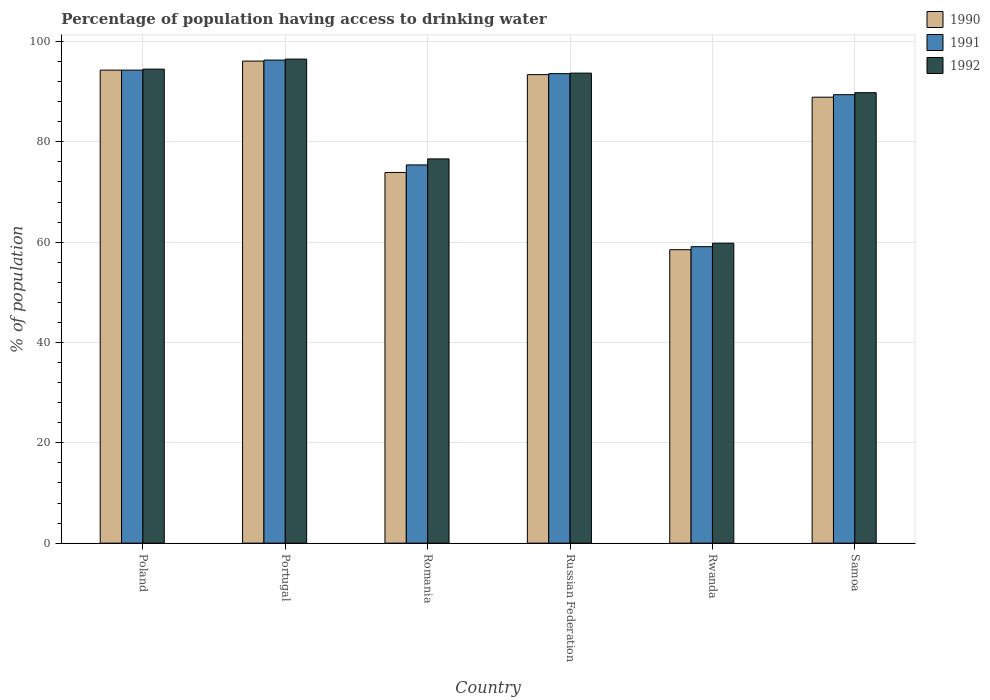How many different coloured bars are there?
Give a very brief answer. 3. How many groups of bars are there?
Your response must be concise. 6. Are the number of bars per tick equal to the number of legend labels?
Keep it short and to the point. Yes. How many bars are there on the 2nd tick from the left?
Your response must be concise. 3. How many bars are there on the 6th tick from the right?
Provide a succinct answer. 3. What is the label of the 6th group of bars from the left?
Offer a very short reply. Samoa. In how many cases, is the number of bars for a given country not equal to the number of legend labels?
Give a very brief answer. 0. What is the percentage of population having access to drinking water in 1992 in Poland?
Offer a terse response. 94.5. Across all countries, what is the maximum percentage of population having access to drinking water in 1990?
Your answer should be compact. 96.1. Across all countries, what is the minimum percentage of population having access to drinking water in 1992?
Your answer should be compact. 59.8. In which country was the percentage of population having access to drinking water in 1991 minimum?
Provide a short and direct response. Rwanda. What is the total percentage of population having access to drinking water in 1992 in the graph?
Provide a succinct answer. 510.9. What is the difference between the percentage of population having access to drinking water in 1991 in Russian Federation and that in Samoa?
Your response must be concise. 4.2. What is the difference between the percentage of population having access to drinking water in 1990 in Samoa and the percentage of population having access to drinking water in 1992 in Russian Federation?
Ensure brevity in your answer.  -4.8. What is the average percentage of population having access to drinking water in 1992 per country?
Your response must be concise. 85.15. What is the difference between the percentage of population having access to drinking water of/in 1990 and percentage of population having access to drinking water of/in 1991 in Portugal?
Make the answer very short. -0.2. What is the ratio of the percentage of population having access to drinking water in 1991 in Russian Federation to that in Rwanda?
Offer a very short reply. 1.58. Is the percentage of population having access to drinking water in 1992 in Romania less than that in Russian Federation?
Provide a succinct answer. Yes. Is the difference between the percentage of population having access to drinking water in 1990 in Russian Federation and Rwanda greater than the difference between the percentage of population having access to drinking water in 1991 in Russian Federation and Rwanda?
Make the answer very short. Yes. What is the difference between the highest and the second highest percentage of population having access to drinking water in 1990?
Give a very brief answer. 2.7. What is the difference between the highest and the lowest percentage of population having access to drinking water in 1992?
Ensure brevity in your answer.  36.7. How many bars are there?
Your response must be concise. 18. What is the difference between two consecutive major ticks on the Y-axis?
Make the answer very short. 20. Are the values on the major ticks of Y-axis written in scientific E-notation?
Your response must be concise. No. Does the graph contain any zero values?
Offer a terse response. No. Does the graph contain grids?
Provide a succinct answer. Yes. What is the title of the graph?
Keep it short and to the point. Percentage of population having access to drinking water. What is the label or title of the Y-axis?
Give a very brief answer. % of population. What is the % of population of 1990 in Poland?
Make the answer very short. 94.3. What is the % of population in 1991 in Poland?
Your response must be concise. 94.3. What is the % of population in 1992 in Poland?
Provide a succinct answer. 94.5. What is the % of population in 1990 in Portugal?
Ensure brevity in your answer.  96.1. What is the % of population of 1991 in Portugal?
Keep it short and to the point. 96.3. What is the % of population of 1992 in Portugal?
Your answer should be very brief. 96.5. What is the % of population in 1990 in Romania?
Your answer should be compact. 73.9. What is the % of population in 1991 in Romania?
Provide a short and direct response. 75.4. What is the % of population of 1992 in Romania?
Offer a very short reply. 76.6. What is the % of population of 1990 in Russian Federation?
Provide a short and direct response. 93.4. What is the % of population in 1991 in Russian Federation?
Ensure brevity in your answer.  93.6. What is the % of population in 1992 in Russian Federation?
Provide a succinct answer. 93.7. What is the % of population in 1990 in Rwanda?
Your answer should be very brief. 58.5. What is the % of population of 1991 in Rwanda?
Provide a short and direct response. 59.1. What is the % of population in 1992 in Rwanda?
Your answer should be compact. 59.8. What is the % of population in 1990 in Samoa?
Provide a succinct answer. 88.9. What is the % of population in 1991 in Samoa?
Keep it short and to the point. 89.4. What is the % of population of 1992 in Samoa?
Ensure brevity in your answer.  89.8. Across all countries, what is the maximum % of population of 1990?
Your answer should be compact. 96.1. Across all countries, what is the maximum % of population in 1991?
Your answer should be very brief. 96.3. Across all countries, what is the maximum % of population of 1992?
Your response must be concise. 96.5. Across all countries, what is the minimum % of population of 1990?
Give a very brief answer. 58.5. Across all countries, what is the minimum % of population in 1991?
Offer a terse response. 59.1. Across all countries, what is the minimum % of population in 1992?
Your answer should be very brief. 59.8. What is the total % of population in 1990 in the graph?
Your answer should be very brief. 505.1. What is the total % of population of 1991 in the graph?
Offer a terse response. 508.1. What is the total % of population of 1992 in the graph?
Ensure brevity in your answer.  510.9. What is the difference between the % of population of 1991 in Poland and that in Portugal?
Your response must be concise. -2. What is the difference between the % of population in 1990 in Poland and that in Romania?
Provide a succinct answer. 20.4. What is the difference between the % of population in 1990 in Poland and that in Russian Federation?
Offer a terse response. 0.9. What is the difference between the % of population of 1990 in Poland and that in Rwanda?
Make the answer very short. 35.8. What is the difference between the % of population in 1991 in Poland and that in Rwanda?
Your answer should be very brief. 35.2. What is the difference between the % of population of 1992 in Poland and that in Rwanda?
Ensure brevity in your answer.  34.7. What is the difference between the % of population of 1991 in Poland and that in Samoa?
Your response must be concise. 4.9. What is the difference between the % of population in 1992 in Poland and that in Samoa?
Your response must be concise. 4.7. What is the difference between the % of population in 1991 in Portugal and that in Romania?
Make the answer very short. 20.9. What is the difference between the % of population in 1992 in Portugal and that in Romania?
Provide a succinct answer. 19.9. What is the difference between the % of population of 1992 in Portugal and that in Russian Federation?
Provide a short and direct response. 2.8. What is the difference between the % of population in 1990 in Portugal and that in Rwanda?
Give a very brief answer. 37.6. What is the difference between the % of population of 1991 in Portugal and that in Rwanda?
Ensure brevity in your answer.  37.2. What is the difference between the % of population of 1992 in Portugal and that in Rwanda?
Keep it short and to the point. 36.7. What is the difference between the % of population in 1990 in Portugal and that in Samoa?
Your answer should be very brief. 7.2. What is the difference between the % of population in 1991 in Portugal and that in Samoa?
Provide a succinct answer. 6.9. What is the difference between the % of population of 1990 in Romania and that in Russian Federation?
Provide a short and direct response. -19.5. What is the difference between the % of population of 1991 in Romania and that in Russian Federation?
Give a very brief answer. -18.2. What is the difference between the % of population in 1992 in Romania and that in Russian Federation?
Provide a short and direct response. -17.1. What is the difference between the % of population in 1990 in Romania and that in Rwanda?
Offer a terse response. 15.4. What is the difference between the % of population in 1991 in Romania and that in Rwanda?
Your response must be concise. 16.3. What is the difference between the % of population in 1990 in Romania and that in Samoa?
Make the answer very short. -15. What is the difference between the % of population of 1991 in Romania and that in Samoa?
Your answer should be compact. -14. What is the difference between the % of population of 1992 in Romania and that in Samoa?
Your response must be concise. -13.2. What is the difference between the % of population in 1990 in Russian Federation and that in Rwanda?
Keep it short and to the point. 34.9. What is the difference between the % of population in 1991 in Russian Federation and that in Rwanda?
Provide a short and direct response. 34.5. What is the difference between the % of population in 1992 in Russian Federation and that in Rwanda?
Offer a very short reply. 33.9. What is the difference between the % of population in 1990 in Russian Federation and that in Samoa?
Provide a short and direct response. 4.5. What is the difference between the % of population of 1990 in Rwanda and that in Samoa?
Your response must be concise. -30.4. What is the difference between the % of population in 1991 in Rwanda and that in Samoa?
Ensure brevity in your answer.  -30.3. What is the difference between the % of population of 1991 in Poland and the % of population of 1992 in Portugal?
Offer a terse response. -2.2. What is the difference between the % of population of 1991 in Poland and the % of population of 1992 in Romania?
Make the answer very short. 17.7. What is the difference between the % of population of 1990 in Poland and the % of population of 1991 in Russian Federation?
Make the answer very short. 0.7. What is the difference between the % of population in 1990 in Poland and the % of population in 1992 in Russian Federation?
Your response must be concise. 0.6. What is the difference between the % of population of 1990 in Poland and the % of population of 1991 in Rwanda?
Your answer should be very brief. 35.2. What is the difference between the % of population in 1990 in Poland and the % of population in 1992 in Rwanda?
Keep it short and to the point. 34.5. What is the difference between the % of population of 1991 in Poland and the % of population of 1992 in Rwanda?
Give a very brief answer. 34.5. What is the difference between the % of population of 1990 in Poland and the % of population of 1991 in Samoa?
Provide a short and direct response. 4.9. What is the difference between the % of population of 1990 in Poland and the % of population of 1992 in Samoa?
Offer a terse response. 4.5. What is the difference between the % of population of 1990 in Portugal and the % of population of 1991 in Romania?
Offer a terse response. 20.7. What is the difference between the % of population in 1991 in Portugal and the % of population in 1992 in Romania?
Offer a terse response. 19.7. What is the difference between the % of population of 1990 in Portugal and the % of population of 1992 in Russian Federation?
Your response must be concise. 2.4. What is the difference between the % of population of 1990 in Portugal and the % of population of 1991 in Rwanda?
Provide a succinct answer. 37. What is the difference between the % of population of 1990 in Portugal and the % of population of 1992 in Rwanda?
Provide a succinct answer. 36.3. What is the difference between the % of population of 1991 in Portugal and the % of population of 1992 in Rwanda?
Offer a terse response. 36.5. What is the difference between the % of population in 1990 in Portugal and the % of population in 1992 in Samoa?
Offer a very short reply. 6.3. What is the difference between the % of population in 1991 in Portugal and the % of population in 1992 in Samoa?
Provide a short and direct response. 6.5. What is the difference between the % of population of 1990 in Romania and the % of population of 1991 in Russian Federation?
Your response must be concise. -19.7. What is the difference between the % of population in 1990 in Romania and the % of population in 1992 in Russian Federation?
Your response must be concise. -19.8. What is the difference between the % of population in 1991 in Romania and the % of population in 1992 in Russian Federation?
Offer a terse response. -18.3. What is the difference between the % of population in 1990 in Romania and the % of population in 1992 in Rwanda?
Provide a short and direct response. 14.1. What is the difference between the % of population in 1991 in Romania and the % of population in 1992 in Rwanda?
Provide a succinct answer. 15.6. What is the difference between the % of population in 1990 in Romania and the % of population in 1991 in Samoa?
Ensure brevity in your answer.  -15.5. What is the difference between the % of population in 1990 in Romania and the % of population in 1992 in Samoa?
Make the answer very short. -15.9. What is the difference between the % of population in 1991 in Romania and the % of population in 1992 in Samoa?
Provide a short and direct response. -14.4. What is the difference between the % of population of 1990 in Russian Federation and the % of population of 1991 in Rwanda?
Give a very brief answer. 34.3. What is the difference between the % of population of 1990 in Russian Federation and the % of population of 1992 in Rwanda?
Give a very brief answer. 33.6. What is the difference between the % of population of 1991 in Russian Federation and the % of population of 1992 in Rwanda?
Keep it short and to the point. 33.8. What is the difference between the % of population of 1990 in Russian Federation and the % of population of 1991 in Samoa?
Your answer should be very brief. 4. What is the difference between the % of population of 1991 in Russian Federation and the % of population of 1992 in Samoa?
Provide a short and direct response. 3.8. What is the difference between the % of population of 1990 in Rwanda and the % of population of 1991 in Samoa?
Offer a terse response. -30.9. What is the difference between the % of population of 1990 in Rwanda and the % of population of 1992 in Samoa?
Give a very brief answer. -31.3. What is the difference between the % of population in 1991 in Rwanda and the % of population in 1992 in Samoa?
Make the answer very short. -30.7. What is the average % of population of 1990 per country?
Ensure brevity in your answer.  84.18. What is the average % of population in 1991 per country?
Provide a succinct answer. 84.68. What is the average % of population in 1992 per country?
Ensure brevity in your answer.  85.15. What is the difference between the % of population of 1990 and % of population of 1991 in Poland?
Provide a succinct answer. 0. What is the difference between the % of population in 1990 and % of population in 1992 in Poland?
Offer a very short reply. -0.2. What is the difference between the % of population of 1991 and % of population of 1992 in Poland?
Provide a short and direct response. -0.2. What is the difference between the % of population in 1990 and % of population in 1991 in Portugal?
Provide a short and direct response. -0.2. What is the difference between the % of population in 1990 and % of population in 1992 in Portugal?
Make the answer very short. -0.4. What is the difference between the % of population in 1991 and % of population in 1992 in Portugal?
Provide a short and direct response. -0.2. What is the difference between the % of population in 1990 and % of population in 1992 in Russian Federation?
Your answer should be compact. -0.3. What is the difference between the % of population of 1990 and % of population of 1991 in Rwanda?
Your response must be concise. -0.6. What is the difference between the % of population of 1991 and % of population of 1992 in Rwanda?
Your response must be concise. -0.7. What is the difference between the % of population in 1991 and % of population in 1992 in Samoa?
Your answer should be very brief. -0.4. What is the ratio of the % of population of 1990 in Poland to that in Portugal?
Your response must be concise. 0.98. What is the ratio of the % of population of 1991 in Poland to that in Portugal?
Offer a terse response. 0.98. What is the ratio of the % of population of 1992 in Poland to that in Portugal?
Ensure brevity in your answer.  0.98. What is the ratio of the % of population in 1990 in Poland to that in Romania?
Provide a short and direct response. 1.28. What is the ratio of the % of population in 1991 in Poland to that in Romania?
Provide a short and direct response. 1.25. What is the ratio of the % of population of 1992 in Poland to that in Romania?
Offer a very short reply. 1.23. What is the ratio of the % of population in 1990 in Poland to that in Russian Federation?
Give a very brief answer. 1.01. What is the ratio of the % of population in 1991 in Poland to that in Russian Federation?
Provide a succinct answer. 1.01. What is the ratio of the % of population in 1992 in Poland to that in Russian Federation?
Provide a short and direct response. 1.01. What is the ratio of the % of population in 1990 in Poland to that in Rwanda?
Offer a very short reply. 1.61. What is the ratio of the % of population in 1991 in Poland to that in Rwanda?
Offer a terse response. 1.6. What is the ratio of the % of population of 1992 in Poland to that in Rwanda?
Your answer should be compact. 1.58. What is the ratio of the % of population in 1990 in Poland to that in Samoa?
Provide a succinct answer. 1.06. What is the ratio of the % of population in 1991 in Poland to that in Samoa?
Ensure brevity in your answer.  1.05. What is the ratio of the % of population of 1992 in Poland to that in Samoa?
Offer a very short reply. 1.05. What is the ratio of the % of population of 1990 in Portugal to that in Romania?
Your answer should be very brief. 1.3. What is the ratio of the % of population in 1991 in Portugal to that in Romania?
Offer a terse response. 1.28. What is the ratio of the % of population of 1992 in Portugal to that in Romania?
Offer a very short reply. 1.26. What is the ratio of the % of population in 1990 in Portugal to that in Russian Federation?
Offer a terse response. 1.03. What is the ratio of the % of population in 1991 in Portugal to that in Russian Federation?
Offer a terse response. 1.03. What is the ratio of the % of population in 1992 in Portugal to that in Russian Federation?
Keep it short and to the point. 1.03. What is the ratio of the % of population in 1990 in Portugal to that in Rwanda?
Your response must be concise. 1.64. What is the ratio of the % of population of 1991 in Portugal to that in Rwanda?
Keep it short and to the point. 1.63. What is the ratio of the % of population of 1992 in Portugal to that in Rwanda?
Provide a succinct answer. 1.61. What is the ratio of the % of population in 1990 in Portugal to that in Samoa?
Your answer should be compact. 1.08. What is the ratio of the % of population in 1991 in Portugal to that in Samoa?
Ensure brevity in your answer.  1.08. What is the ratio of the % of population in 1992 in Portugal to that in Samoa?
Your response must be concise. 1.07. What is the ratio of the % of population of 1990 in Romania to that in Russian Federation?
Offer a very short reply. 0.79. What is the ratio of the % of population in 1991 in Romania to that in Russian Federation?
Keep it short and to the point. 0.81. What is the ratio of the % of population in 1992 in Romania to that in Russian Federation?
Keep it short and to the point. 0.82. What is the ratio of the % of population of 1990 in Romania to that in Rwanda?
Your answer should be very brief. 1.26. What is the ratio of the % of population in 1991 in Romania to that in Rwanda?
Your answer should be very brief. 1.28. What is the ratio of the % of population in 1992 in Romania to that in Rwanda?
Make the answer very short. 1.28. What is the ratio of the % of population of 1990 in Romania to that in Samoa?
Your response must be concise. 0.83. What is the ratio of the % of population of 1991 in Romania to that in Samoa?
Your response must be concise. 0.84. What is the ratio of the % of population in 1992 in Romania to that in Samoa?
Offer a very short reply. 0.85. What is the ratio of the % of population in 1990 in Russian Federation to that in Rwanda?
Provide a short and direct response. 1.6. What is the ratio of the % of population of 1991 in Russian Federation to that in Rwanda?
Offer a very short reply. 1.58. What is the ratio of the % of population in 1992 in Russian Federation to that in Rwanda?
Give a very brief answer. 1.57. What is the ratio of the % of population of 1990 in Russian Federation to that in Samoa?
Your response must be concise. 1.05. What is the ratio of the % of population in 1991 in Russian Federation to that in Samoa?
Keep it short and to the point. 1.05. What is the ratio of the % of population in 1992 in Russian Federation to that in Samoa?
Give a very brief answer. 1.04. What is the ratio of the % of population of 1990 in Rwanda to that in Samoa?
Ensure brevity in your answer.  0.66. What is the ratio of the % of population of 1991 in Rwanda to that in Samoa?
Give a very brief answer. 0.66. What is the ratio of the % of population of 1992 in Rwanda to that in Samoa?
Your answer should be very brief. 0.67. What is the difference between the highest and the lowest % of population in 1990?
Your response must be concise. 37.6. What is the difference between the highest and the lowest % of population of 1991?
Give a very brief answer. 37.2. What is the difference between the highest and the lowest % of population of 1992?
Your response must be concise. 36.7. 